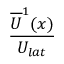Convert formula to latex. <formula><loc_0><loc_0><loc_500><loc_500>\frac { \overline { U } ^ { 1 } ( x ) } { U _ { l a t } }</formula> 